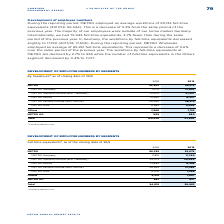According to Metro Ag's financial document, When are the employee numbers by segments counted? as of closing date of 30/9. The document states: "By headcount 1 as of closing date of 30/9..." Also, What is excluded in the headcount as of closing date of 30/9? According to the financial document, METRO China.. The relevant text states: "1 Excluding METRO China...." Also, What are the different segments under METRO when accounting for the employee numbers by segments? The document contains multiple relevant values: METRO Germany, METRO Western Europe (excl.Germany), METRO Russia, METRO Eastern Europe (excl.Russia), METRO Asia. From the document: "METRO Germany 13,711 13,606 METRO Russia 13,960 12,357 METRO Asia 8,665 8,009..." Additionally, In which year was the amount in METRO Asia headcount larger? According to the financial document, 2018. The relevant text states: "2018 2019..." Also, can you calculate: What was the change in METRO AG headcount in 2019 from 2018? Based on the calculation: 880-909, the result is -29. This is based on the information: "METRO AG 909 880 METRO AG 909 880..." The key data points involved are: 880, 909. Also, can you calculate: What was the percentage change in METRO AG headcount in 2019 from 2018? To answer this question, I need to perform calculations using the financial data. The calculation is: (880-909)/909, which equals -3.19 (percentage). This is based on the information: "METRO AG 909 880 METRO AG 909 880..." The key data points involved are: 880, 909. 